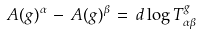<formula> <loc_0><loc_0><loc_500><loc_500>A ( g ) ^ { \alpha } \, - \, A ( g ) ^ { \beta } \, = \, d \log T ^ { g } _ { \alpha \beta }</formula> 